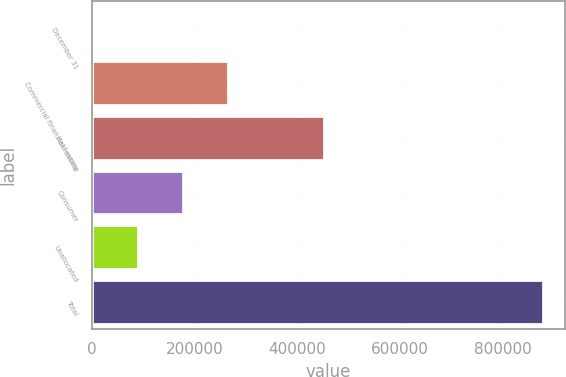<chart> <loc_0><loc_0><loc_500><loc_500><bar_chart><fcel>December 31<fcel>Commercial financial leasing<fcel>Real estate<fcel>Consumer<fcel>Unallocated<fcel>Total<nl><fcel>2009<fcel>264813<fcel>451352<fcel>177212<fcel>89610.3<fcel>878022<nl></chart> 